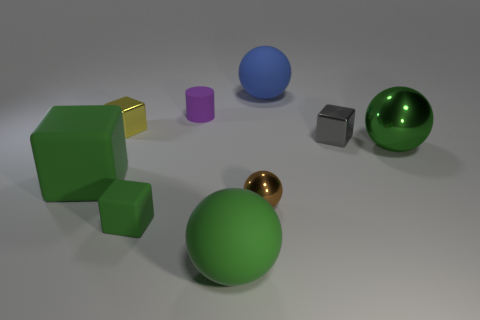Can you estimate the size of the green sphere compared to the other objects? Without specific measurements, it's a rough estimate, but the green sphere appears to be slightly larger than the blue sphere and significantly larger than the small silver cube and golden sphere beside it. 